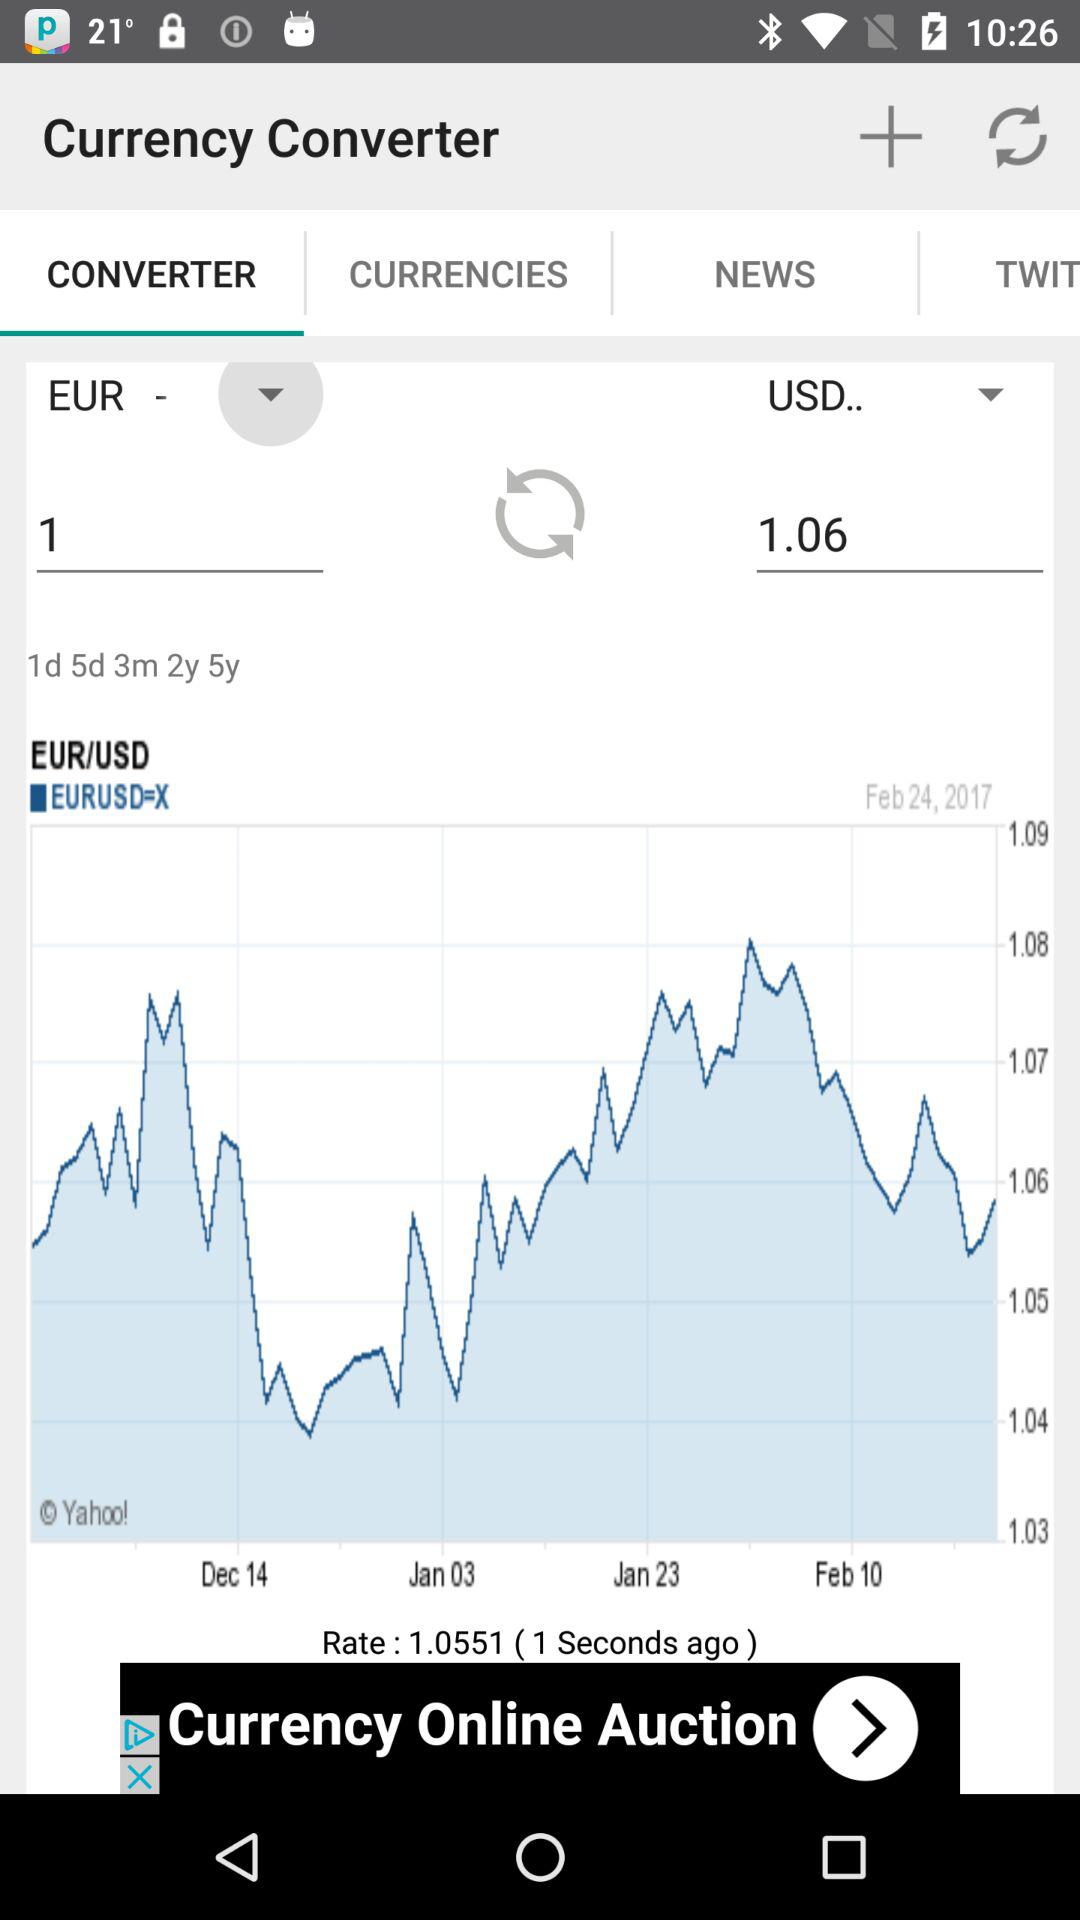What is the value of 1.06 USD in EUR? The value of 1.06 USD is 1 EUR. 